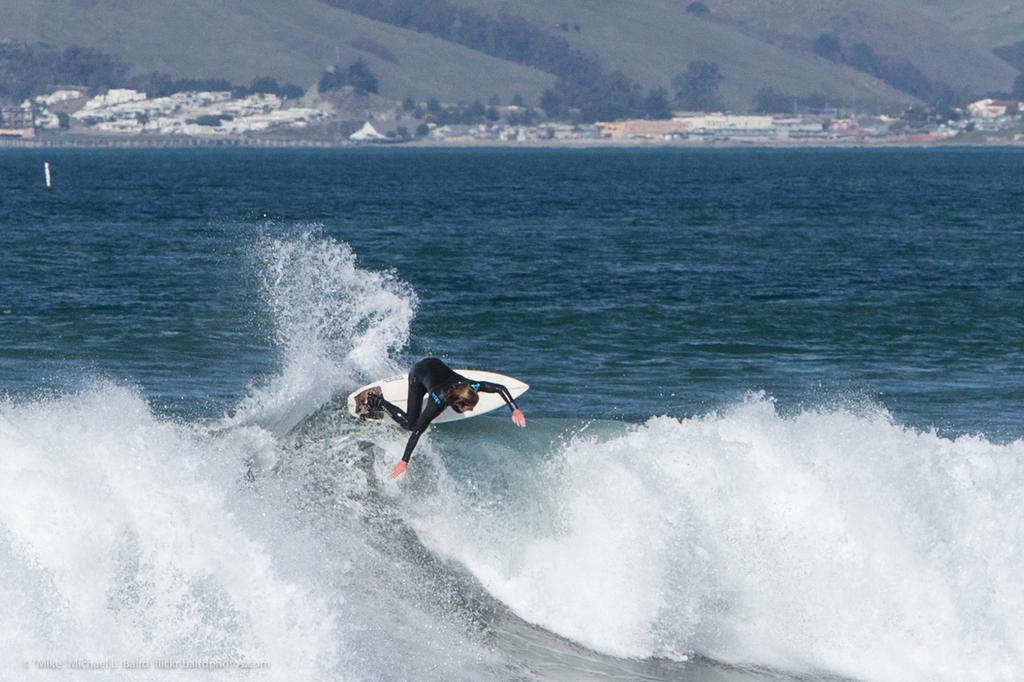What is the person in the image doing? The person is surfing in the sea. What is the person wearing while surfing? The person is wearing a black dress. What can be seen in the background of the image? There are houses and trees visible at the top of the image. What is the name of the shop where the person bought the black dress? There is no information about a shop or the person buying the dress in the image. 